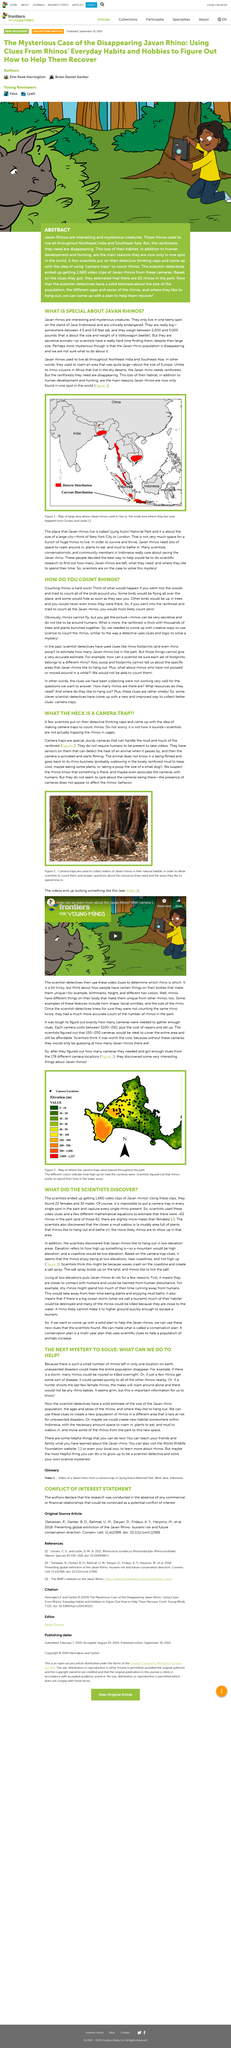Draw attention to some important aspects in this diagram. The scientists discovered something interesting about the Javan Rhino after placing 178 cameras in their environment. The Javan rhino population is disappearing due to the loss of their rainforest habitat and hunting by humans. Scientists put on their thinking caps to help them with their research and scientific experiments. Javan rhinos, a species of rhino, once lived throughout Northeast India and Southeast Asia. Scientists are actively searching for rhinos in their quest to discover more about these fascinating creatures. 